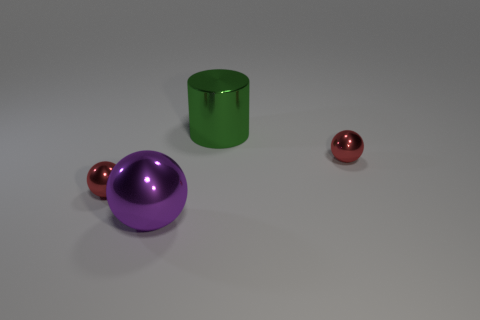Subtract all red spheres. How many spheres are left? 1 Subtract all cyan cubes. How many red balls are left? 2 Add 1 small red shiny balls. How many objects exist? 5 Subtract all red balls. How many balls are left? 1 Subtract 1 spheres. How many spheres are left? 2 Add 1 purple shiny objects. How many purple shiny objects are left? 2 Add 1 large purple metal spheres. How many large purple metal spheres exist? 2 Subtract 0 gray cubes. How many objects are left? 4 Subtract all cylinders. How many objects are left? 3 Subtract all blue cylinders. Subtract all yellow cubes. How many cylinders are left? 1 